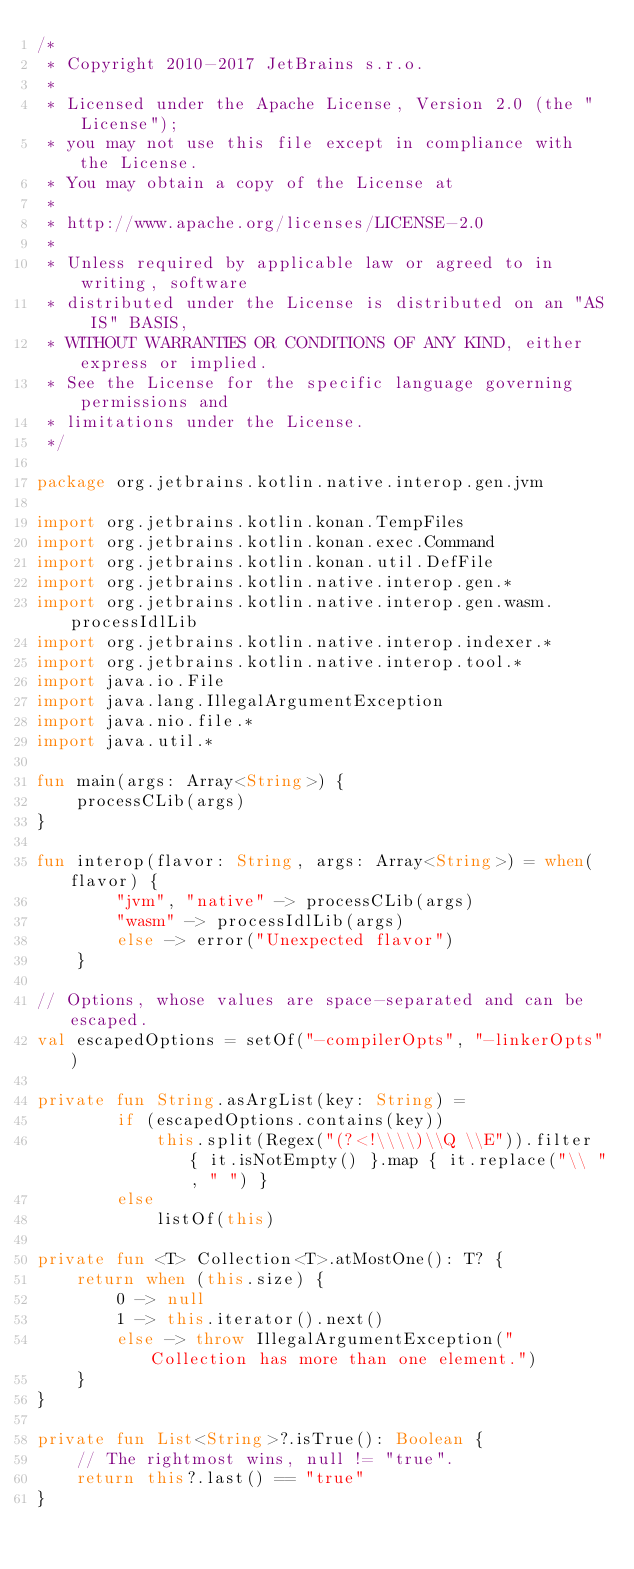<code> <loc_0><loc_0><loc_500><loc_500><_Kotlin_>/*
 * Copyright 2010-2017 JetBrains s.r.o.
 *
 * Licensed under the Apache License, Version 2.0 (the "License");
 * you may not use this file except in compliance with the License.
 * You may obtain a copy of the License at
 *
 * http://www.apache.org/licenses/LICENSE-2.0
 *
 * Unless required by applicable law or agreed to in writing, software
 * distributed under the License is distributed on an "AS IS" BASIS,
 * WITHOUT WARRANTIES OR CONDITIONS OF ANY KIND, either express or implied.
 * See the License for the specific language governing permissions and
 * limitations under the License.
 */

package org.jetbrains.kotlin.native.interop.gen.jvm

import org.jetbrains.kotlin.konan.TempFiles
import org.jetbrains.kotlin.konan.exec.Command
import org.jetbrains.kotlin.konan.util.DefFile
import org.jetbrains.kotlin.native.interop.gen.*
import org.jetbrains.kotlin.native.interop.gen.wasm.processIdlLib
import org.jetbrains.kotlin.native.interop.indexer.*
import org.jetbrains.kotlin.native.interop.tool.*
import java.io.File
import java.lang.IllegalArgumentException
import java.nio.file.*
import java.util.*

fun main(args: Array<String>) {
    processCLib(args)
}

fun interop(flavor: String, args: Array<String>) = when(flavor) {
        "jvm", "native" -> processCLib(args)
        "wasm" -> processIdlLib(args)
        else -> error("Unexpected flavor")
    }

// Options, whose values are space-separated and can be escaped.
val escapedOptions = setOf("-compilerOpts", "-linkerOpts")

private fun String.asArgList(key: String) =
        if (escapedOptions.contains(key))
            this.split(Regex("(?<!\\\\)\\Q \\E")).filter { it.isNotEmpty() }.map { it.replace("\\ ", " ") }
        else
            listOf(this)

private fun <T> Collection<T>.atMostOne(): T? {
    return when (this.size) {
        0 -> null
        1 -> this.iterator().next()
        else -> throw IllegalArgumentException("Collection has more than one element.")
    }
}

private fun List<String>?.isTrue(): Boolean {
    // The rightmost wins, null != "true".
    return this?.last() == "true"
}
</code> 